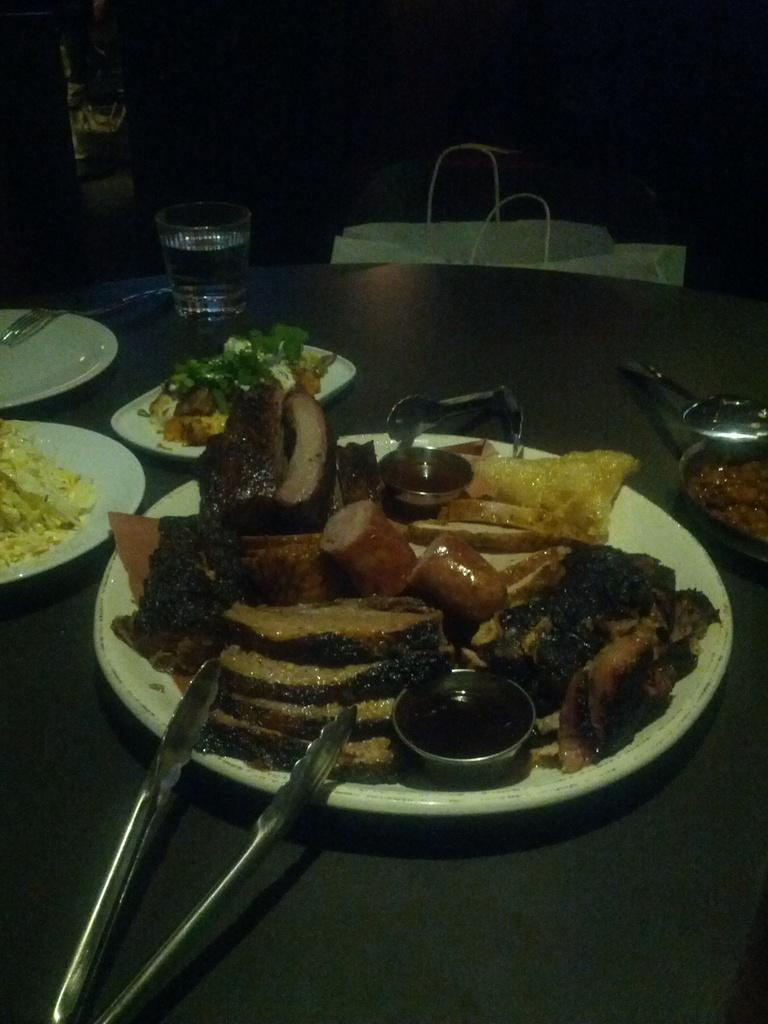What piece of furniture is present in the image? There is a table in the image. What items are placed on the table? There are plates, spoons, glasses, food items, and unspecified objects on the table. What might be used for eating or drinking in the image? Spoons and glasses are present on the table for eating and drinking. What is located in front of the table? There is a bag in front of the table. What type of ship can be seen sailing in the background of the image? There is no ship visible in the image; it only features a table with various items on it and a bag in front of it. 